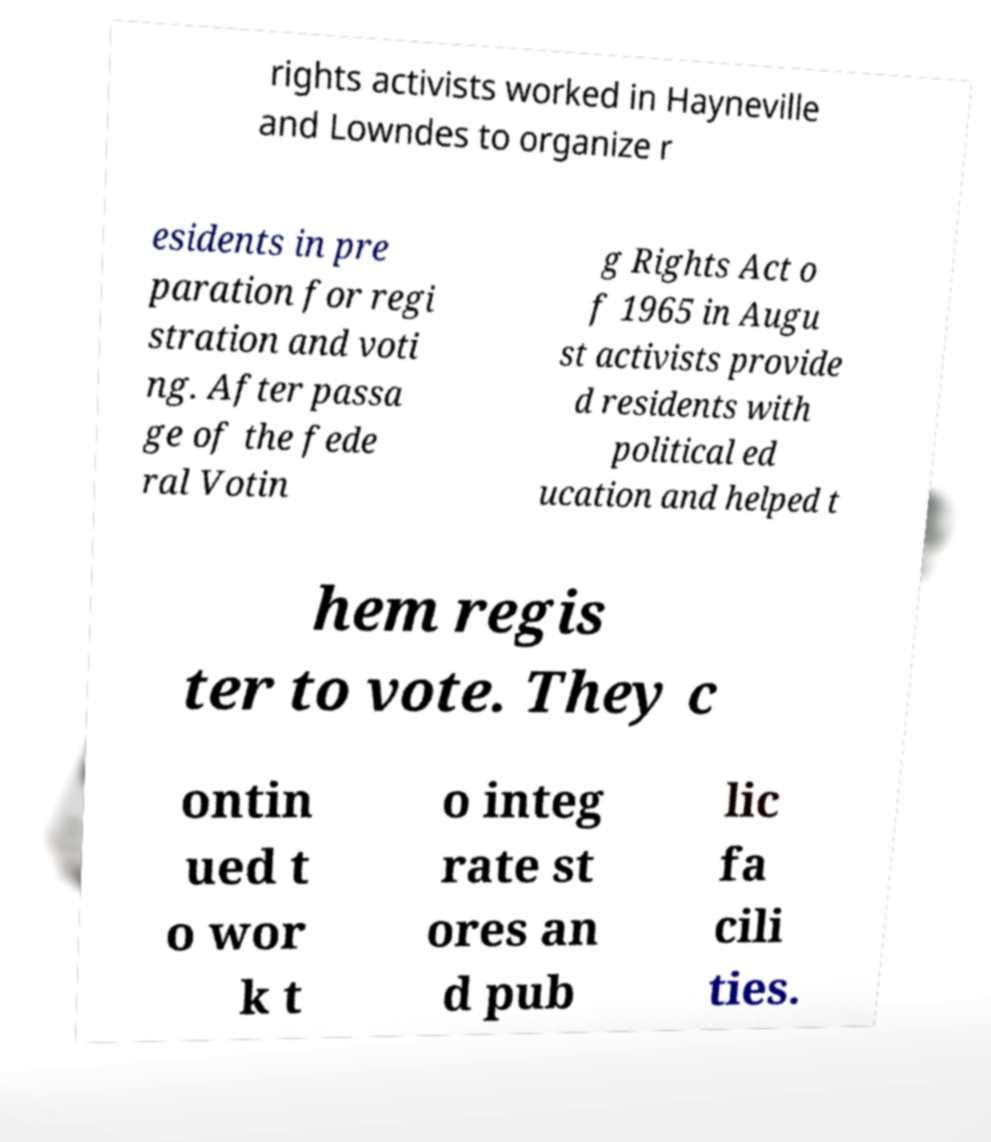Could you assist in decoding the text presented in this image and type it out clearly? rights activists worked in Hayneville and Lowndes to organize r esidents in pre paration for regi stration and voti ng. After passa ge of the fede ral Votin g Rights Act o f 1965 in Augu st activists provide d residents with political ed ucation and helped t hem regis ter to vote. They c ontin ued t o wor k t o integ rate st ores an d pub lic fa cili ties. 